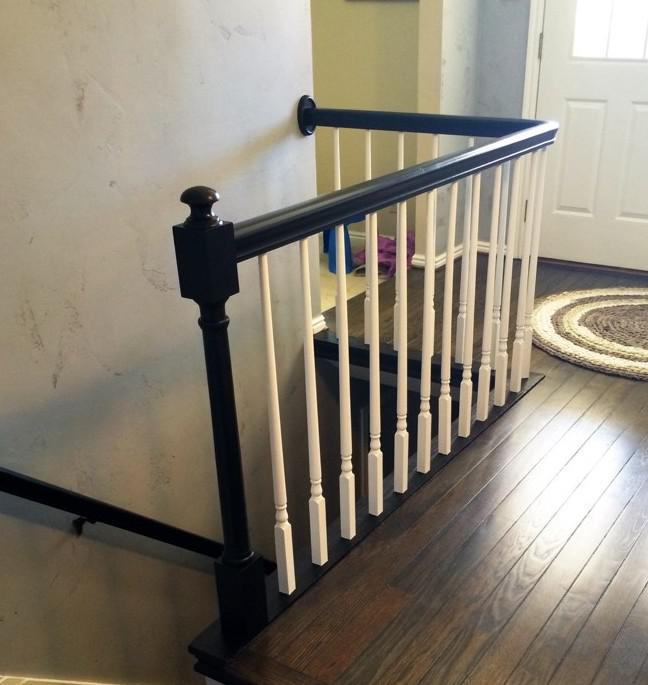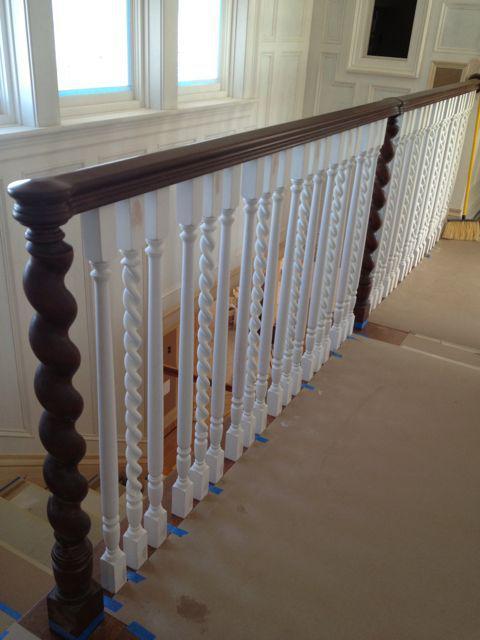The first image is the image on the left, the second image is the image on the right. Evaluate the accuracy of this statement regarding the images: "Each image shows at least one square corner post and straight white bars flanking a descending flight of stairs.". Is it true? Answer yes or no. No. The first image is the image on the left, the second image is the image on the right. Assess this claim about the two images: "All of the banister posts are painted white.". Correct or not? Answer yes or no. No. 